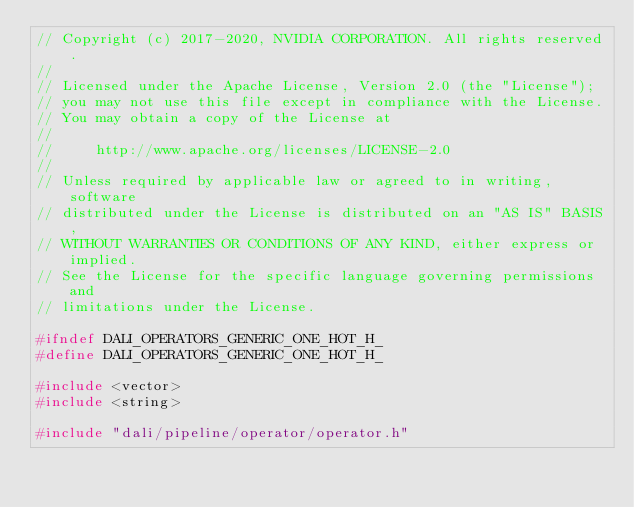<code> <loc_0><loc_0><loc_500><loc_500><_C_>// Copyright (c) 2017-2020, NVIDIA CORPORATION. All rights reserved.
//
// Licensed under the Apache License, Version 2.0 (the "License");
// you may not use this file except in compliance with the License.
// You may obtain a copy of the License at
//
//     http://www.apache.org/licenses/LICENSE-2.0
//
// Unless required by applicable law or agreed to in writing, software
// distributed under the License is distributed on an "AS IS" BASIS,
// WITHOUT WARRANTIES OR CONDITIONS OF ANY KIND, either express or implied.
// See the License for the specific language governing permissions and
// limitations under the License.

#ifndef DALI_OPERATORS_GENERIC_ONE_HOT_H_
#define DALI_OPERATORS_GENERIC_ONE_HOT_H_

#include <vector>
#include <string>

#include "dali/pipeline/operator/operator.h"</code> 